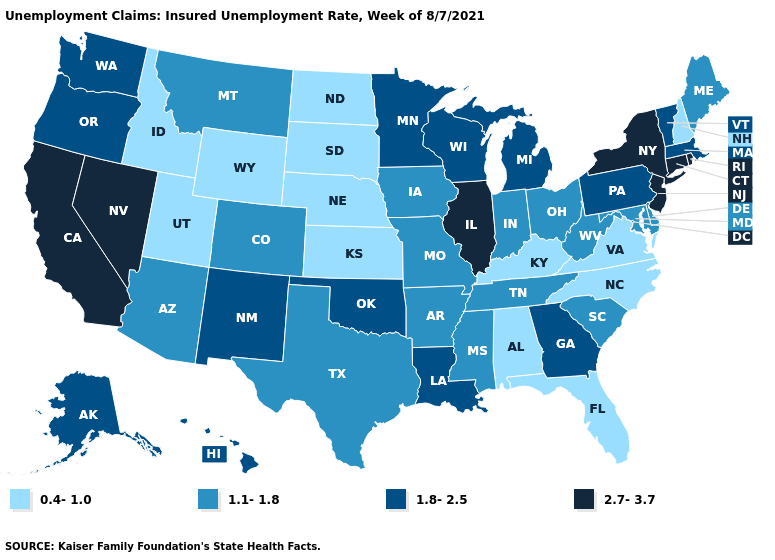Name the states that have a value in the range 0.4-1.0?
Quick response, please. Alabama, Florida, Idaho, Kansas, Kentucky, Nebraska, New Hampshire, North Carolina, North Dakota, South Dakota, Utah, Virginia, Wyoming. Name the states that have a value in the range 1.8-2.5?
Give a very brief answer. Alaska, Georgia, Hawaii, Louisiana, Massachusetts, Michigan, Minnesota, New Mexico, Oklahoma, Oregon, Pennsylvania, Vermont, Washington, Wisconsin. Does Alabama have a lower value than South Carolina?
Quick response, please. Yes. What is the lowest value in the USA?
Keep it brief. 0.4-1.0. What is the value of Wyoming?
Be succinct. 0.4-1.0. What is the lowest value in states that border New Hampshire?
Give a very brief answer. 1.1-1.8. What is the value of Arkansas?
Keep it brief. 1.1-1.8. What is the lowest value in the South?
Be succinct. 0.4-1.0. Among the states that border Utah , which have the highest value?
Concise answer only. Nevada. What is the highest value in the USA?
Be succinct. 2.7-3.7. Does Kansas have a lower value than New Hampshire?
Short answer required. No. Which states hav the highest value in the Northeast?
Short answer required. Connecticut, New Jersey, New York, Rhode Island. Does the first symbol in the legend represent the smallest category?
Keep it brief. Yes. Name the states that have a value in the range 1.1-1.8?
Quick response, please. Arizona, Arkansas, Colorado, Delaware, Indiana, Iowa, Maine, Maryland, Mississippi, Missouri, Montana, Ohio, South Carolina, Tennessee, Texas, West Virginia. Does Oklahoma have the highest value in the South?
Concise answer only. Yes. 